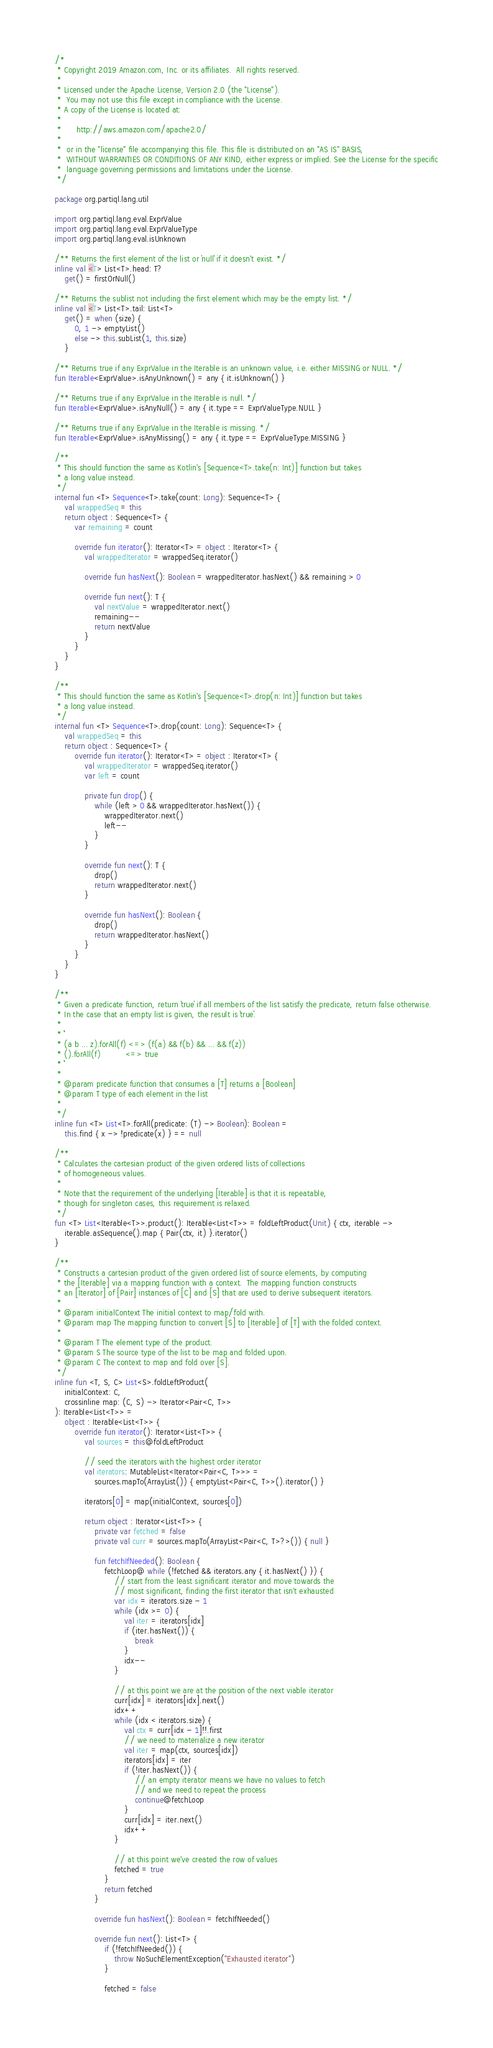Convert code to text. <code><loc_0><loc_0><loc_500><loc_500><_Kotlin_>/*
 * Copyright 2019 Amazon.com, Inc. or its affiliates.  All rights reserved.
 *
 * Licensed under the Apache License, Version 2.0 (the "License").
 *  You may not use this file except in compliance with the License.
 * A copy of the License is located at:
 *
 *      http://aws.amazon.com/apache2.0/
 *
 *  or in the "license" file accompanying this file. This file is distributed on an "AS IS" BASIS,
 *  WITHOUT WARRANTIES OR CONDITIONS OF ANY KIND, either express or implied. See the License for the specific
 *  language governing permissions and limitations under the License.
 */

package org.partiql.lang.util

import org.partiql.lang.eval.ExprValue
import org.partiql.lang.eval.ExprValueType
import org.partiql.lang.eval.isUnknown

/** Returns the first element of the list or `null` if it doesn't exist. */
inline val <T> List<T>.head: T?
    get() = firstOrNull()

/** Returns the sublist not including the first element which may be the empty list. */
inline val <T> List<T>.tail: List<T>
    get() = when (size) {
        0, 1 -> emptyList()
        else -> this.subList(1, this.size)
    }

/** Returns true if any ExprValue in the Iterable is an unknown value, i.e. either MISSING or NULL. */
fun Iterable<ExprValue>.isAnyUnknown() = any { it.isUnknown() }

/** Returns true if any ExprValue in the Iterable is null. */
fun Iterable<ExprValue>.isAnyNull() = any { it.type == ExprValueType.NULL }

/** Returns true if any ExprValue in the Iterable is missing. */
fun Iterable<ExprValue>.isAnyMissing() = any { it.type == ExprValueType.MISSING }

/**
 * This should function the same as Kotlin's [Sequence<T>.take(n: Int)] function but takes
 * a long value instead.
 */
internal fun <T> Sequence<T>.take(count: Long): Sequence<T> {
    val wrappedSeq = this
    return object : Sequence<T> {
        var remaining = count

        override fun iterator(): Iterator<T> = object : Iterator<T> {
            val wrappedIterator = wrappedSeq.iterator()

            override fun hasNext(): Boolean = wrappedIterator.hasNext() && remaining > 0

            override fun next(): T {
                val nextValue = wrappedIterator.next()
                remaining--
                return nextValue
            }
        }
    }
}

/**
 * This should function the same as Kotlin's [Sequence<T>.drop(n: Int)] function but takes
 * a long value instead.
 */
internal fun <T> Sequence<T>.drop(count: Long): Sequence<T> {
    val wrappedSeq = this
    return object : Sequence<T> {
        override fun iterator(): Iterator<T> = object : Iterator<T> {
            val wrappedIterator = wrappedSeq.iterator()
            var left = count

            private fun drop() {
                while (left > 0 && wrappedIterator.hasNext()) {
                    wrappedIterator.next()
                    left--
                }
            }

            override fun next(): T {
                drop()
                return wrappedIterator.next()
            }

            override fun hasNext(): Boolean {
                drop()
                return wrappedIterator.hasNext()
            }
        }
    }
}

/**
 * Given a predicate function, return `true` if all members of the list satisfy the predicate, return false otherwise.
 * In the case that an empty list is given, the result is `true`.
 *
 * ```
 * (a b ... z).forAll(f) <=> (f(a) && f(b) && ... && f(z))
 * ().forAll(f)          <=> true
 * ```
 *
 * @param predicate function that consumes a [T] returns a [Boolean]
 * @param T type of each element in the list
 *
 */
inline fun <T> List<T>.forAll(predicate: (T) -> Boolean): Boolean =
    this.find { x -> !predicate(x) } == null

/**
 * Calculates the cartesian product of the given ordered lists of collections
 * of homogeneous values.
 *
 * Note that the requirement of the underlying [Iterable] is that it is repeatable,
 * though for singleton cases, this requirement is relaxed.
 */
fun <T> List<Iterable<T>>.product(): Iterable<List<T>> = foldLeftProduct(Unit) { ctx, iterable ->
    iterable.asSequence().map { Pair(ctx, it) }.iterator()
}

/**
 * Constructs a cartesian product of the given ordered list of source elements, by computing
 * the [Iterable] via a mapping function with a context.  The mapping function constructs
 * an [Iterator] of [Pair] instances of [C] and [S] that are used to derive subsequent iterators.
 *
 * @param initialContext The initial context to map/fold with.
 * @param map The mapping function to convert [S] to [Iterable] of [T] with the folded context.
 *
 * @param T The element type of the product.
 * @param S The source type of the list to be map and folded upon.
 * @param C The context to map and fold over [S].
 */
inline fun <T, S, C> List<S>.foldLeftProduct(
    initialContext: C,
    crossinline map: (C, S) -> Iterator<Pair<C, T>>
): Iterable<List<T>> =
    object : Iterable<List<T>> {
        override fun iterator(): Iterator<List<T>> {
            val sources = this@foldLeftProduct

            // seed the iterators with the highest order iterator
            val iterators: MutableList<Iterator<Pair<C, T>>> =
                sources.mapTo(ArrayList()) { emptyList<Pair<C, T>>().iterator() }

            iterators[0] = map(initialContext, sources[0])

            return object : Iterator<List<T>> {
                private var fetched = false
                private val curr = sources.mapTo(ArrayList<Pair<C, T>?>()) { null }

                fun fetchIfNeeded(): Boolean {
                    fetchLoop@ while (!fetched && iterators.any { it.hasNext() }) {
                        // start from the least significant iterator and move towards the
                        // most significant, finding the first iterator that isn't exhausted
                        var idx = iterators.size - 1
                        while (idx >= 0) {
                            val iter = iterators[idx]
                            if (iter.hasNext()) {
                                break
                            }
                            idx--
                        }

                        // at this point we are at the position of the next viable iterator
                        curr[idx] = iterators[idx].next()
                        idx++
                        while (idx < iterators.size) {
                            val ctx = curr[idx - 1]!!.first
                            // we need to materialize a new iterator
                            val iter = map(ctx, sources[idx])
                            iterators[idx] = iter
                            if (!iter.hasNext()) {
                                // an empty iterator means we have no values to fetch
                                // and we need to repeat the process
                                continue@fetchLoop
                            }
                            curr[idx] = iter.next()
                            idx++
                        }

                        // at this point we've created the row of values
                        fetched = true
                    }
                    return fetched
                }

                override fun hasNext(): Boolean = fetchIfNeeded()

                override fun next(): List<T> {
                    if (!fetchIfNeeded()) {
                        throw NoSuchElementException("Exhausted iterator")
                    }

                    fetched = false
</code> 